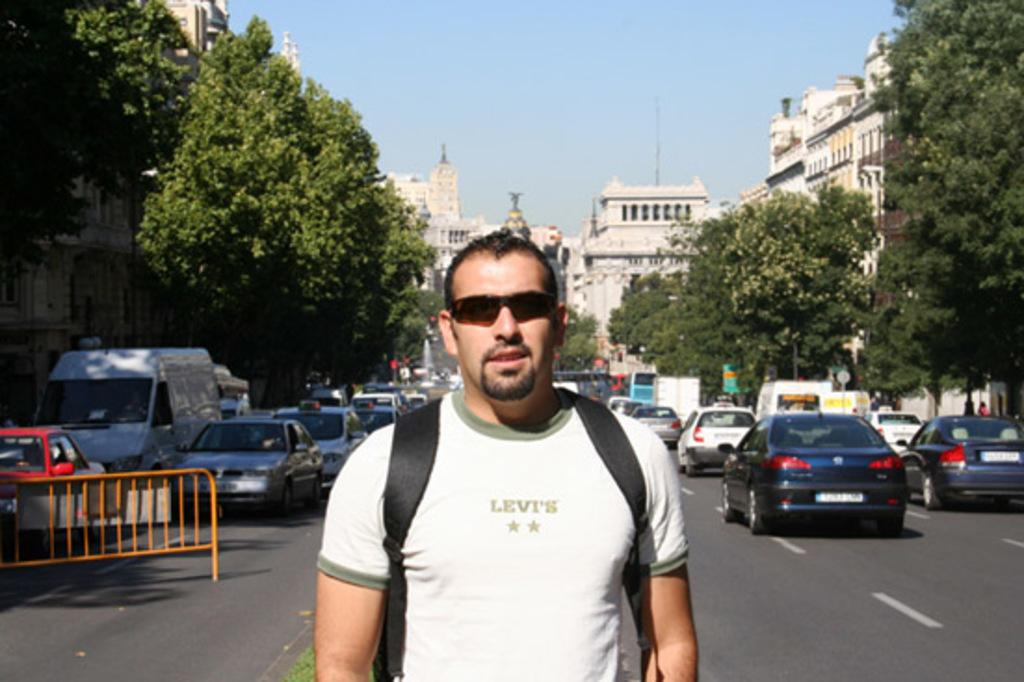What is the man in the image wearing on his face? The man is wearing goggles in the image. What type of terrain is visible in the image? There is grass visible in the image. What objects can be seen in the image that are made of wood? There are boards in the image. What type of vegetation is present in the image? There are trees in the image. What type of transportation is visible on the road in the image? There are vehicles on the road in the image. What type of structures can be seen in the image? There are buildings in the image. What part of the natural environment is visible in the background of the image? The sky is visible in the background of the image. Can you tell me how many basketballs are being smashed by the man in the image? There are no basketballs present in the image, nor is the man smashing anything. 